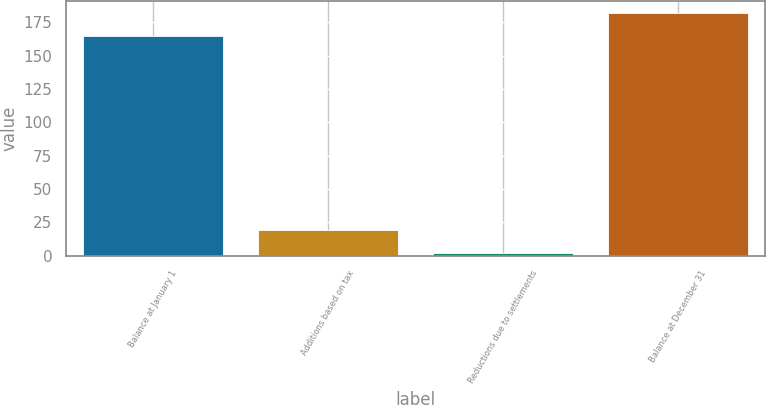<chart> <loc_0><loc_0><loc_500><loc_500><bar_chart><fcel>Balance at January 1<fcel>Additions based on tax<fcel>Reductions due to settlements<fcel>Balance at December 31<nl><fcel>165<fcel>19.3<fcel>2<fcel>182.3<nl></chart> 